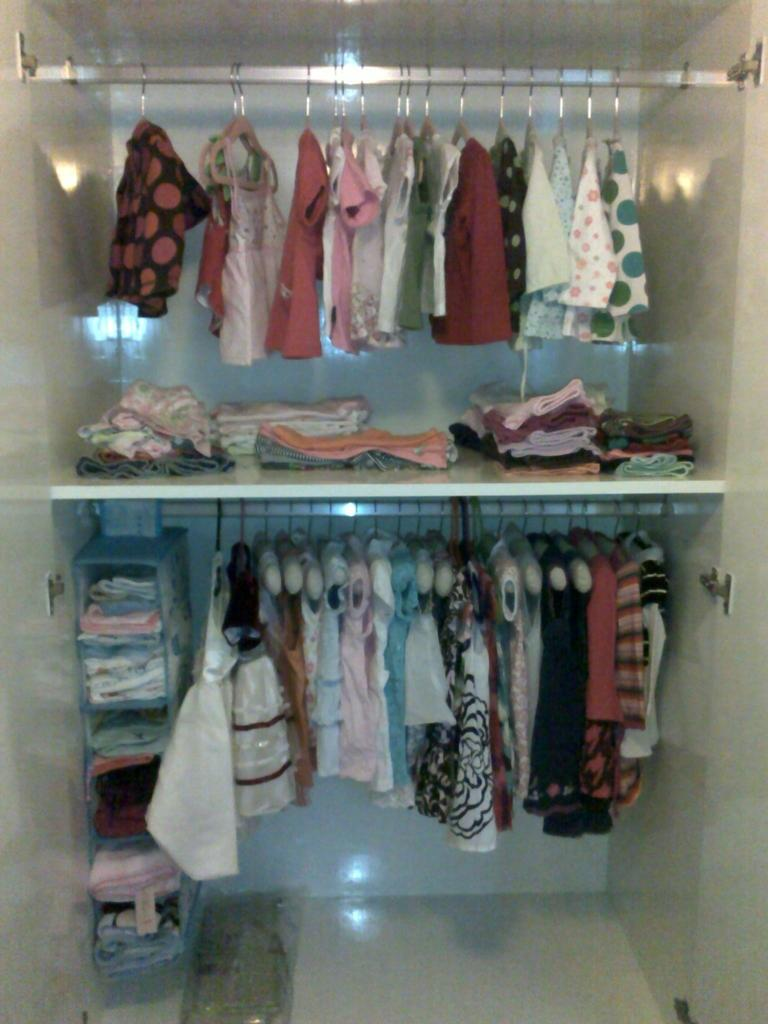What is the primary subject of the image? The primary subject of the image is clothes, which are hung on hangers and placed in a rack. Can you describe the arrangement of the clothes in the image? The clothes are hung on hangers and placed in a rack, which might suggest the presence of a cupboard or closet. Where might this image have been taken? The image might have been taken in a room, such as a bedroom or a closet. How many cherries are visible on the clothes in the image? There are no cherries present in the image; it features clothes hung on hangers and placed in a rack. 